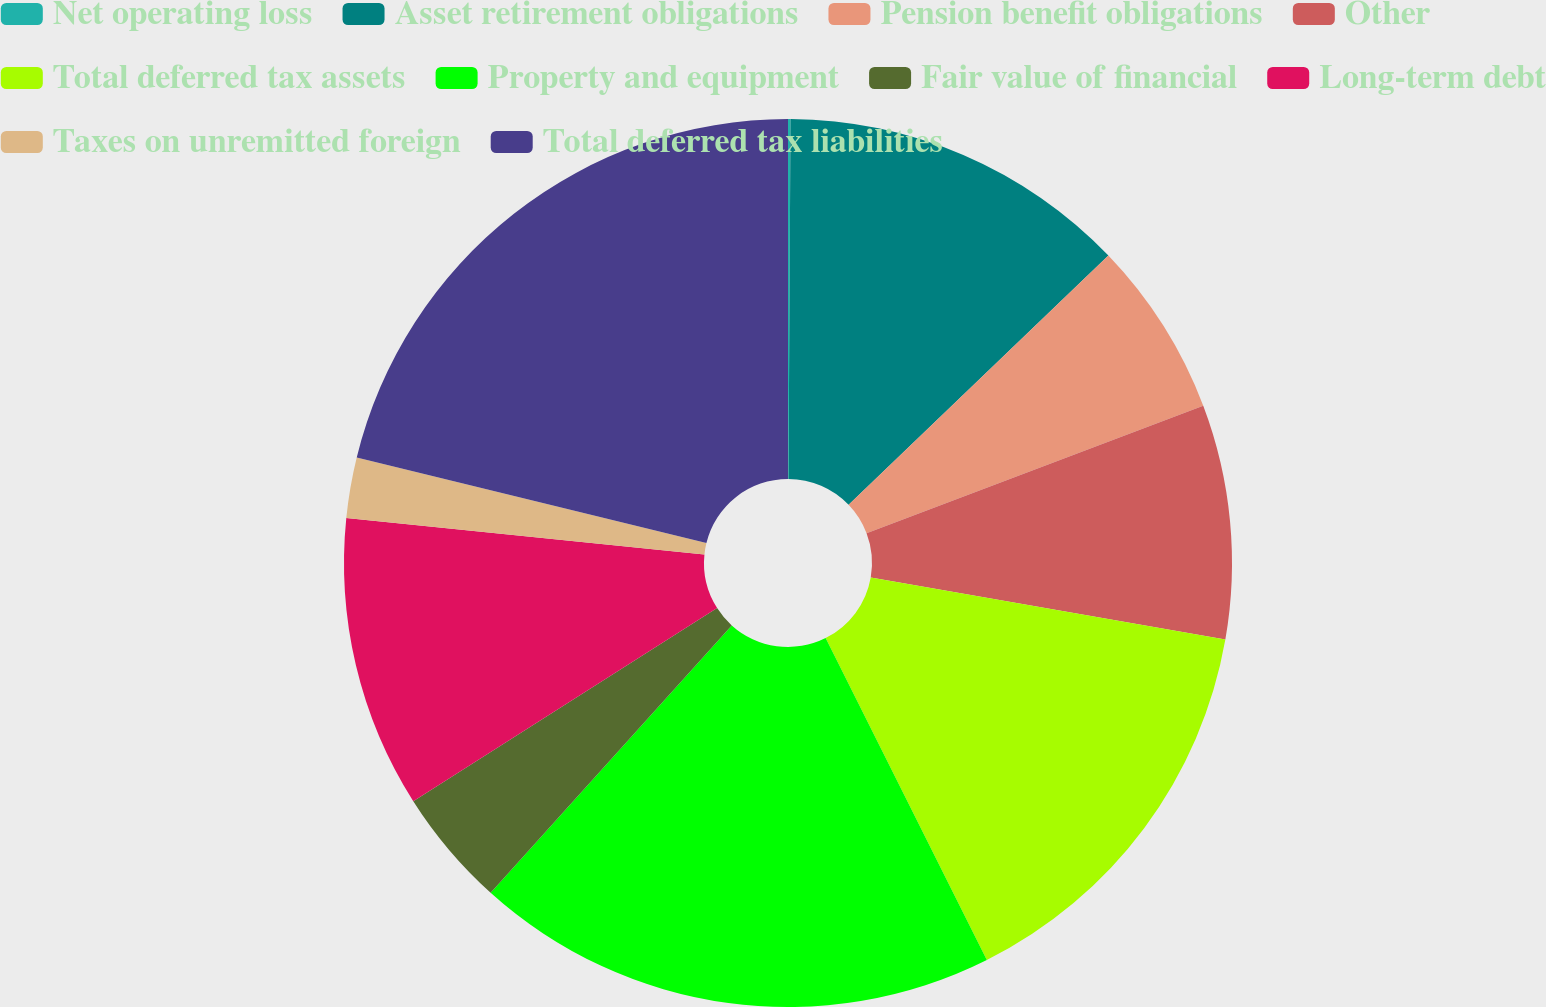Convert chart. <chart><loc_0><loc_0><loc_500><loc_500><pie_chart><fcel>Net operating loss<fcel>Asset retirement obligations<fcel>Pension benefit obligations<fcel>Other<fcel>Total deferred tax assets<fcel>Property and equipment<fcel>Fair value of financial<fcel>Long-term debt<fcel>Taxes on unremitted foreign<fcel>Total deferred tax liabilities<nl><fcel>0.09%<fcel>12.74%<fcel>6.41%<fcel>8.52%<fcel>14.85%<fcel>19.07%<fcel>4.31%<fcel>10.63%<fcel>2.2%<fcel>21.18%<nl></chart> 